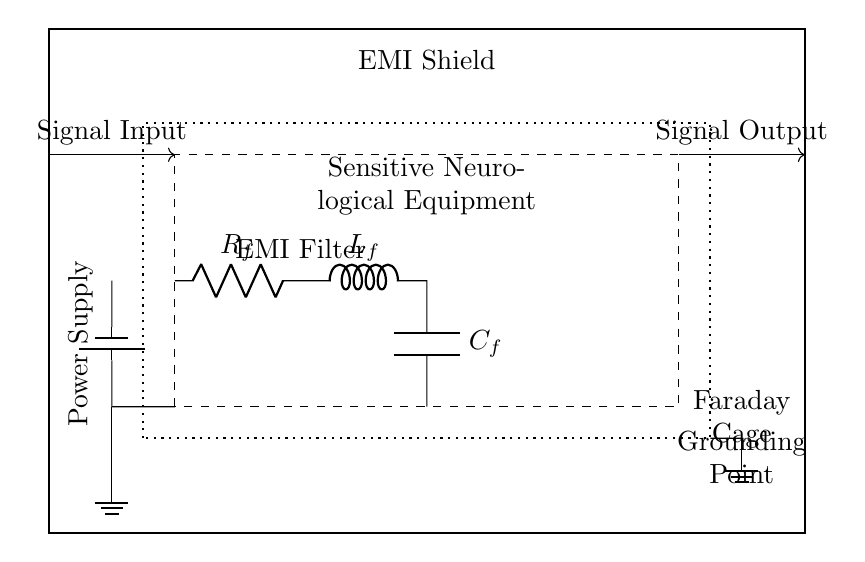What is the type of equipment enclosed in the EMI shield? The diagram shows "Sensitive Neurological Equipment" enclosed within the EMI shield, indicated by the dashed rectangle.
Answer: Sensitive Neurological Equipment What does the dashed outline indicate? The dashed outline represents the boundaries of the sensitive neurological equipment which is protected by the EMI shield.
Answer: Neurological Equipment What is the purpose of the grounding point? The grounding point, indicated at the bottom right, is essential for safely dissipating stray electromagnetic interference, providing a return path for excess charge or noise to the ground.
Answer: Safety Which components are part of the EMI filter? The EMI filter consists of a resistor, inductor, and capacitor, as denoted by the labels R, L, and C in the circuit.
Answer: Resistor, Inductor, Capacitor How are the signal input and output represented in the circuit? The signal input is shown with an arrow coming from the left labeled "Signal Input", and the signal output is an arrow going to the right labeled "Signal Output", illustrating the flow of signals through the system.
Answer: Arrows Why is a Faraday cage included in the design? The Faraday cage, represented by the dotted rectangle, is included to provide a shield against electromagnetic interference, protecting the sensitive neurological equipment inside from external EMI disturbances.
Answer: Shielding What is the role of the power supply in this circuit? The power supply provides the necessary electrical energy to operate the sensitive neurological equipment, as shown by the battery symbol connected to the circuit.
Answer: Energy source 